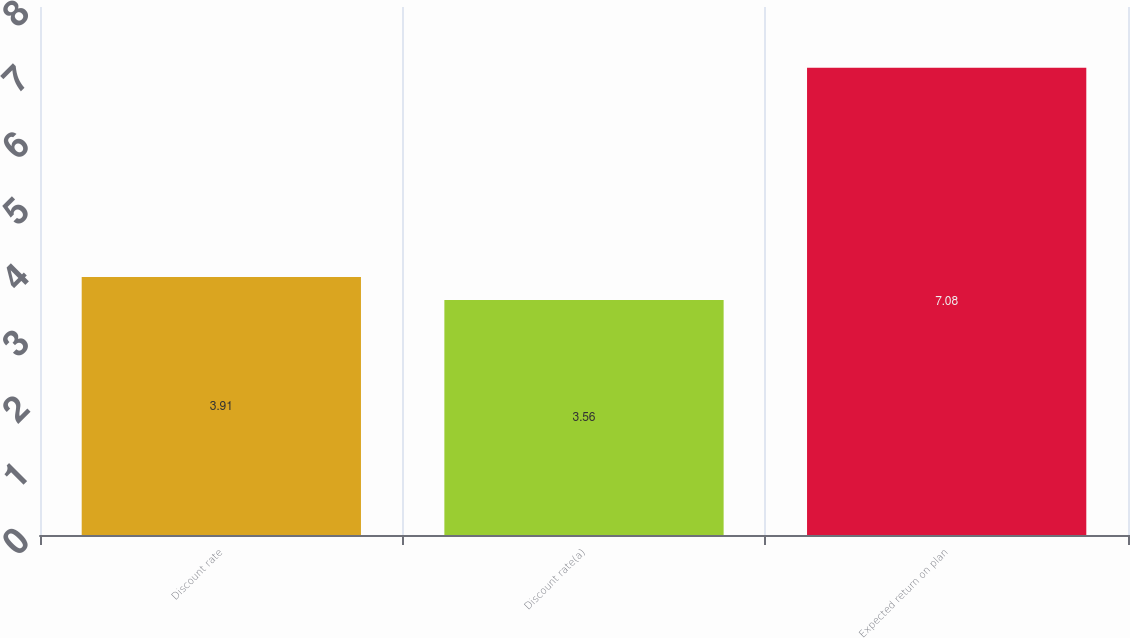<chart> <loc_0><loc_0><loc_500><loc_500><bar_chart><fcel>Discount rate<fcel>Discount rate(a)<fcel>Expected return on plan<nl><fcel>3.91<fcel>3.56<fcel>7.08<nl></chart> 